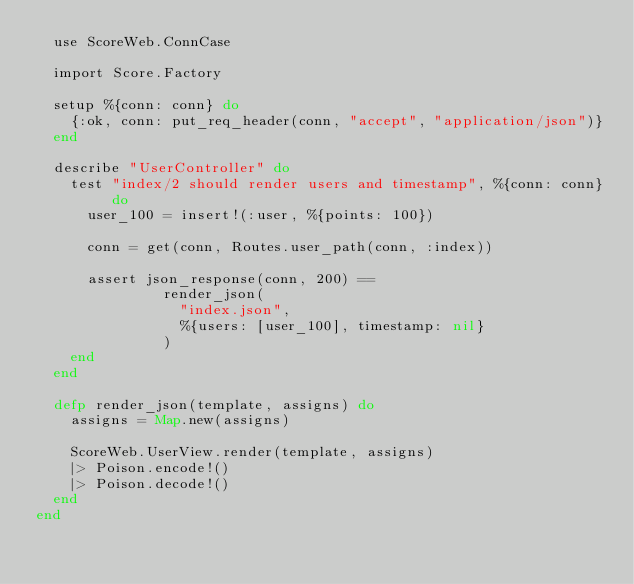Convert code to text. <code><loc_0><loc_0><loc_500><loc_500><_Elixir_>  use ScoreWeb.ConnCase

  import Score.Factory

  setup %{conn: conn} do
    {:ok, conn: put_req_header(conn, "accept", "application/json")}
  end

  describe "UserController" do
    test "index/2 should render users and timestamp", %{conn: conn} do
      user_100 = insert!(:user, %{points: 100})

      conn = get(conn, Routes.user_path(conn, :index))

      assert json_response(conn, 200) ==
               render_json(
                 "index.json",
                 %{users: [user_100], timestamp: nil}
               )
    end
  end

  defp render_json(template, assigns) do
    assigns = Map.new(assigns)

    ScoreWeb.UserView.render(template, assigns)
    |> Poison.encode!()
    |> Poison.decode!()
  end
end
</code> 